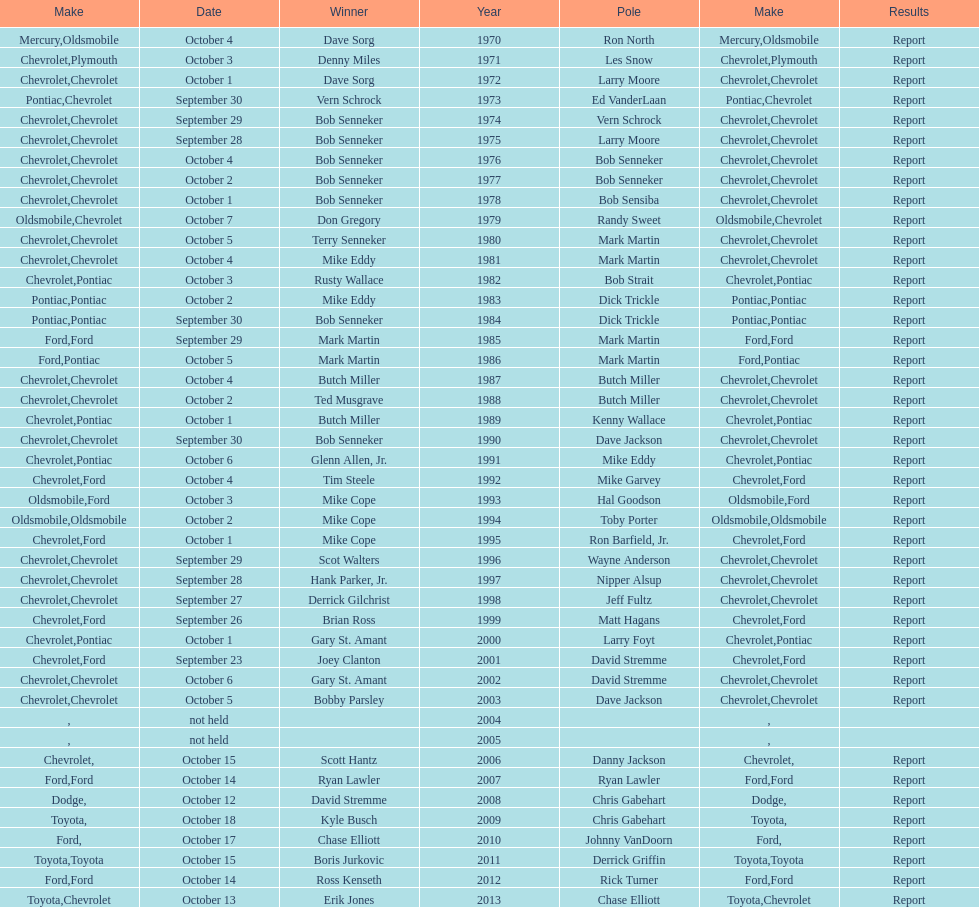How many consecutive wins did bob senneker have? 5. 